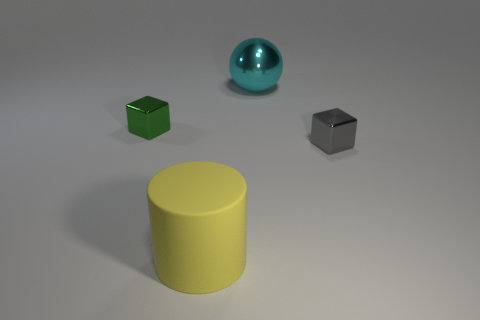What number of cubes are in front of the small cube that is behind the small gray metallic cube?
Provide a short and direct response. 1. What number of blue objects are metallic objects or cylinders?
Make the answer very short. 0. What is the shape of the metal thing that is in front of the metal object left of the metal object that is behind the green thing?
Offer a very short reply. Cube. What is the color of the other metallic cube that is the same size as the gray metallic cube?
Your answer should be very brief. Green. What number of other tiny metal objects have the same shape as the tiny green thing?
Your answer should be compact. 1. There is a cyan thing; is it the same size as the cube that is on the left side of the cylinder?
Offer a very short reply. No. There is a small metal object to the right of the shiny cube that is left of the gray object; what is its shape?
Your response must be concise. Cube. Are there fewer tiny gray metallic cubes that are to the left of the small gray metallic object than tiny blocks?
Keep it short and to the point. Yes. How many other blocks have the same size as the green metal cube?
Offer a terse response. 1. What is the shape of the big thing in front of the green metallic object?
Offer a terse response. Cylinder. 